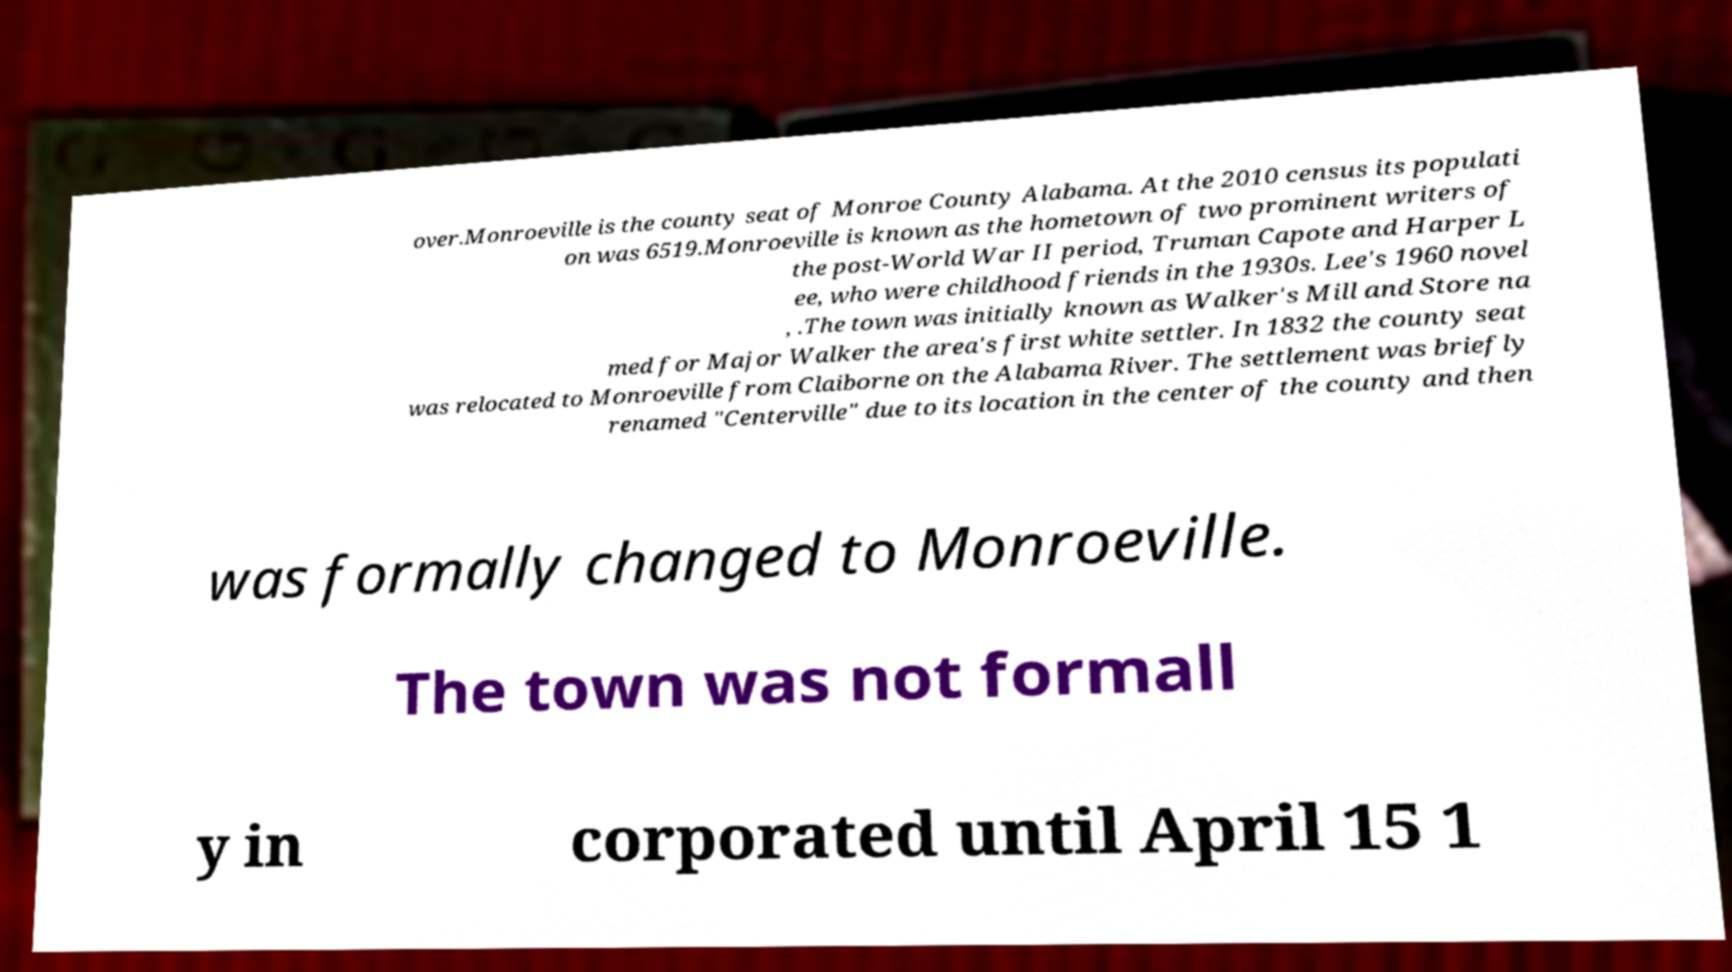Please read and relay the text visible in this image. What does it say? over.Monroeville is the county seat of Monroe County Alabama. At the 2010 census its populati on was 6519.Monroeville is known as the hometown of two prominent writers of the post-World War II period, Truman Capote and Harper L ee, who were childhood friends in the 1930s. Lee's 1960 novel , .The town was initially known as Walker's Mill and Store na med for Major Walker the area's first white settler. In 1832 the county seat was relocated to Monroeville from Claiborne on the Alabama River. The settlement was briefly renamed "Centerville" due to its location in the center of the county and then was formally changed to Monroeville. The town was not formall y in corporated until April 15 1 